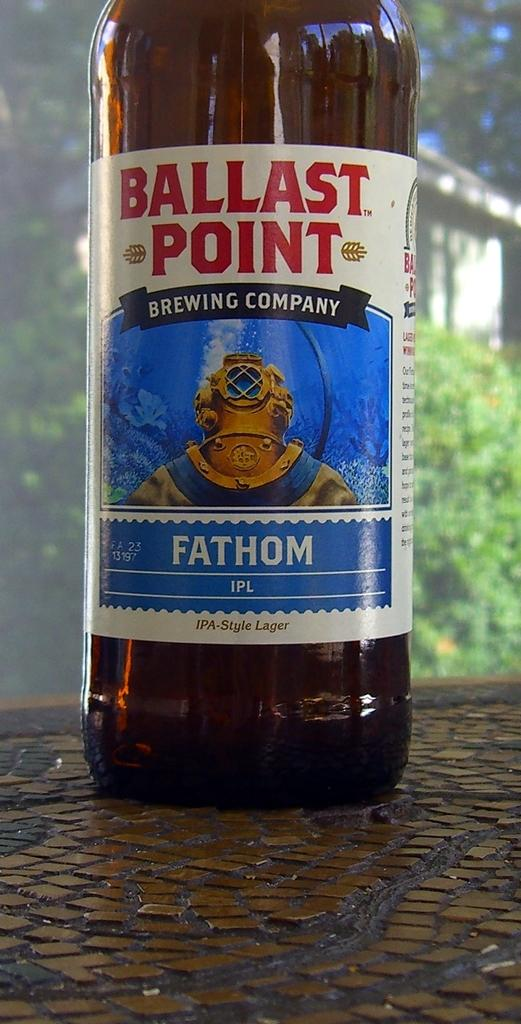Provide a one-sentence caption for the provided image. A beer that is called "Ballast Point" in on a table. 